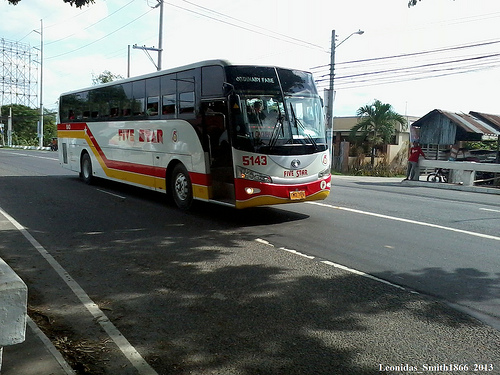Can you tell me about the bus's design and color scheme? The bus in the image has a sleek modern design, predominantly white with red and yellow accents running along its sides, which could be indicative of the company's brand colors. 